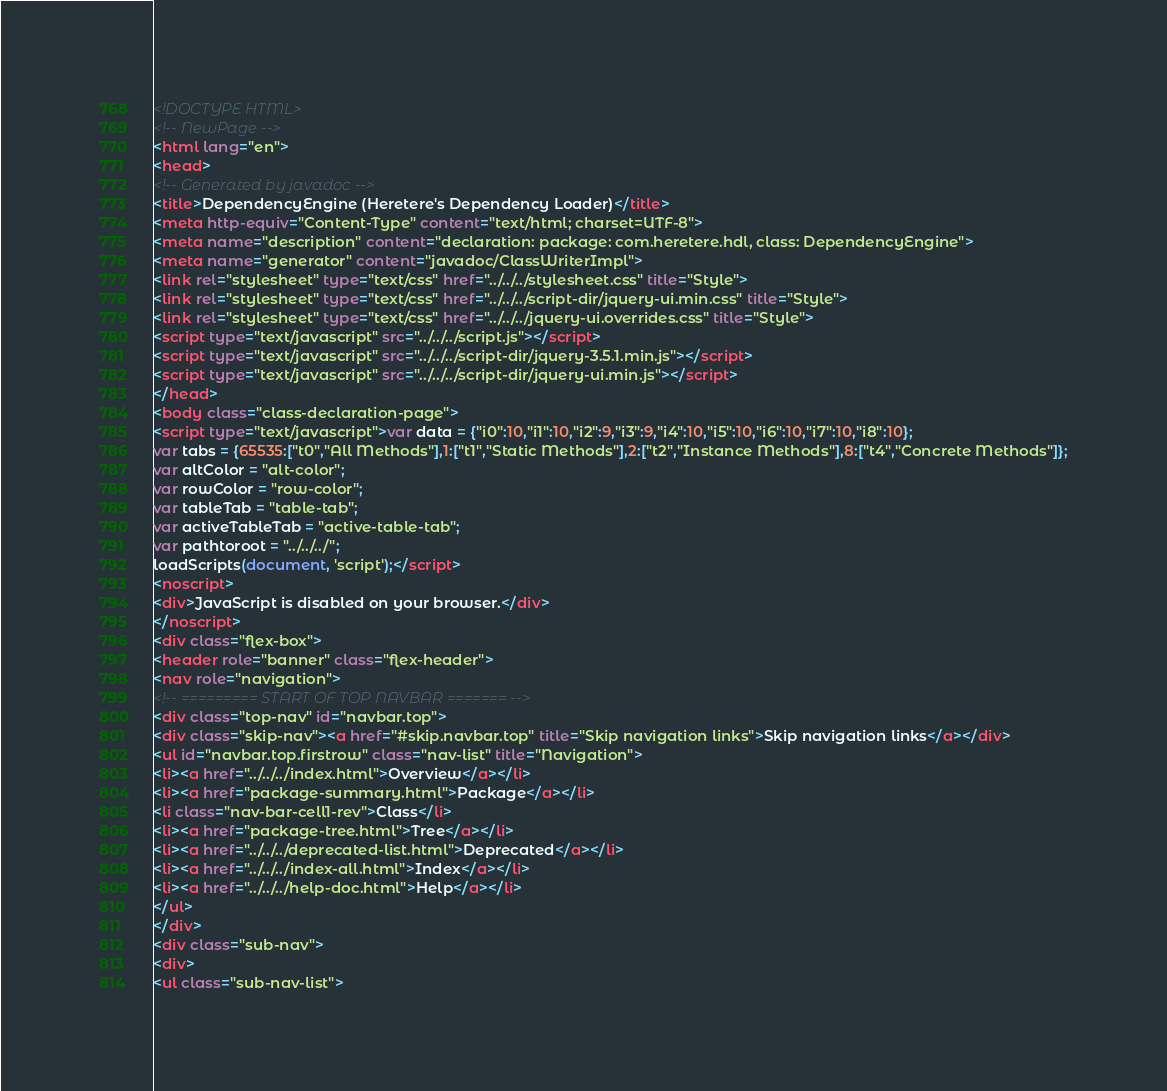Convert code to text. <code><loc_0><loc_0><loc_500><loc_500><_HTML_><!DOCTYPE HTML>
<!-- NewPage -->
<html lang="en">
<head>
<!-- Generated by javadoc -->
<title>DependencyEngine (Heretere's Dependency Loader)</title>
<meta http-equiv="Content-Type" content="text/html; charset=UTF-8">
<meta name="description" content="declaration: package: com.heretere.hdl, class: DependencyEngine">
<meta name="generator" content="javadoc/ClassWriterImpl">
<link rel="stylesheet" type="text/css" href="../../../stylesheet.css" title="Style">
<link rel="stylesheet" type="text/css" href="../../../script-dir/jquery-ui.min.css" title="Style">
<link rel="stylesheet" type="text/css" href="../../../jquery-ui.overrides.css" title="Style">
<script type="text/javascript" src="../../../script.js"></script>
<script type="text/javascript" src="../../../script-dir/jquery-3.5.1.min.js"></script>
<script type="text/javascript" src="../../../script-dir/jquery-ui.min.js"></script>
</head>
<body class="class-declaration-page">
<script type="text/javascript">var data = {"i0":10,"i1":10,"i2":9,"i3":9,"i4":10,"i5":10,"i6":10,"i7":10,"i8":10};
var tabs = {65535:["t0","All Methods"],1:["t1","Static Methods"],2:["t2","Instance Methods"],8:["t4","Concrete Methods"]};
var altColor = "alt-color";
var rowColor = "row-color";
var tableTab = "table-tab";
var activeTableTab = "active-table-tab";
var pathtoroot = "../../../";
loadScripts(document, 'script');</script>
<noscript>
<div>JavaScript is disabled on your browser.</div>
</noscript>
<div class="flex-box">
<header role="banner" class="flex-header">
<nav role="navigation">
<!-- ========= START OF TOP NAVBAR ======= -->
<div class="top-nav" id="navbar.top">
<div class="skip-nav"><a href="#skip.navbar.top" title="Skip navigation links">Skip navigation links</a></div>
<ul id="navbar.top.firstrow" class="nav-list" title="Navigation">
<li><a href="../../../index.html">Overview</a></li>
<li><a href="package-summary.html">Package</a></li>
<li class="nav-bar-cell1-rev">Class</li>
<li><a href="package-tree.html">Tree</a></li>
<li><a href="../../../deprecated-list.html">Deprecated</a></li>
<li><a href="../../../index-all.html">Index</a></li>
<li><a href="../../../help-doc.html">Help</a></li>
</ul>
</div>
<div class="sub-nav">
<div>
<ul class="sub-nav-list"></code> 